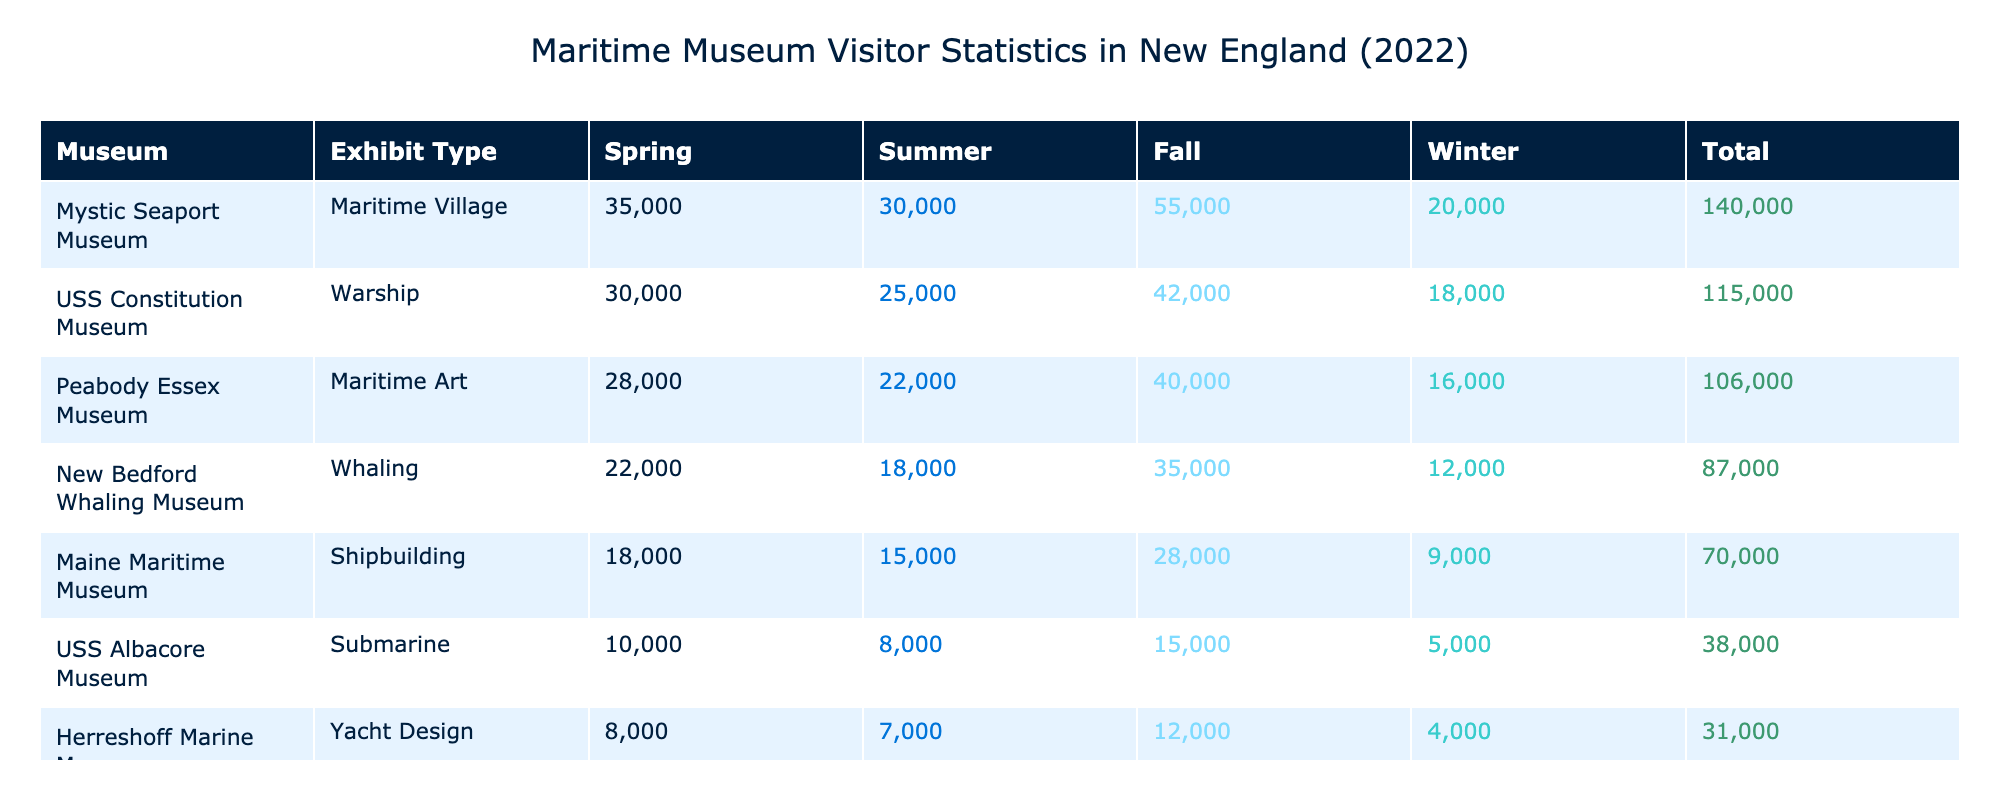What is the total number of visitors to the USS Constitution Museum in 2022? The table shows the visitors for the USS Constitution Museum across all seasons: Spring (25000), Summer (42000), Fall (30000), and Winter (18000). Adding these values gives 25000 + 42000 + 30000 + 18000 = 115000.
Answer: 115000 Which museum had the highest number of visitors in the summer of 2022? In the summer season, the visitor counts are: USS Constitution Museum (42000), New Bedford Whaling Museum (35000), Mystic Seaport Museum (55000), Maine Maritime Museum (28000), and Peabody Essex Museum (40000). The highest is Mystic Seaport Museum with 55000 visitors.
Answer: Mystic Seaport Museum Did the Herreshoff Marine Museum receive more visitors in the Spring or Winter of 2022? For the Herreshoff Marine Museum, the visitor count is: Spring (7000) and Winter (4000). Since 7000 is greater than 4000, it received more visitors in the Spring.
Answer: Yes What was the average number of visitors per season for the New Bedford Whaling Museum? The visitor counts for the New Bedford Whaling Museum across the seasons are: Spring (18000), Summer (35000), Fall (22000), and Winter (12000). The total is 18000 + 35000 + 22000 + 12000 = 87000. There are 4 seasons, so the average is 87000 / 4 = 21750.
Answer: 21750 What is the difference in total visitors between Mystic Seaport Museum and Maine Maritime Museum? For Mystic Seaport Museum, the total visitors are: Spring (30000) + Summer (55000) + Fall (35000) + Winter (20000) = 140000. For Maine Maritime Museum, the totals are: Spring (15000) + Summer (28000) + Fall (18000) + Winter (9000) = 70000. The difference is 140000 - 70000 = 70000.
Answer: 70000 